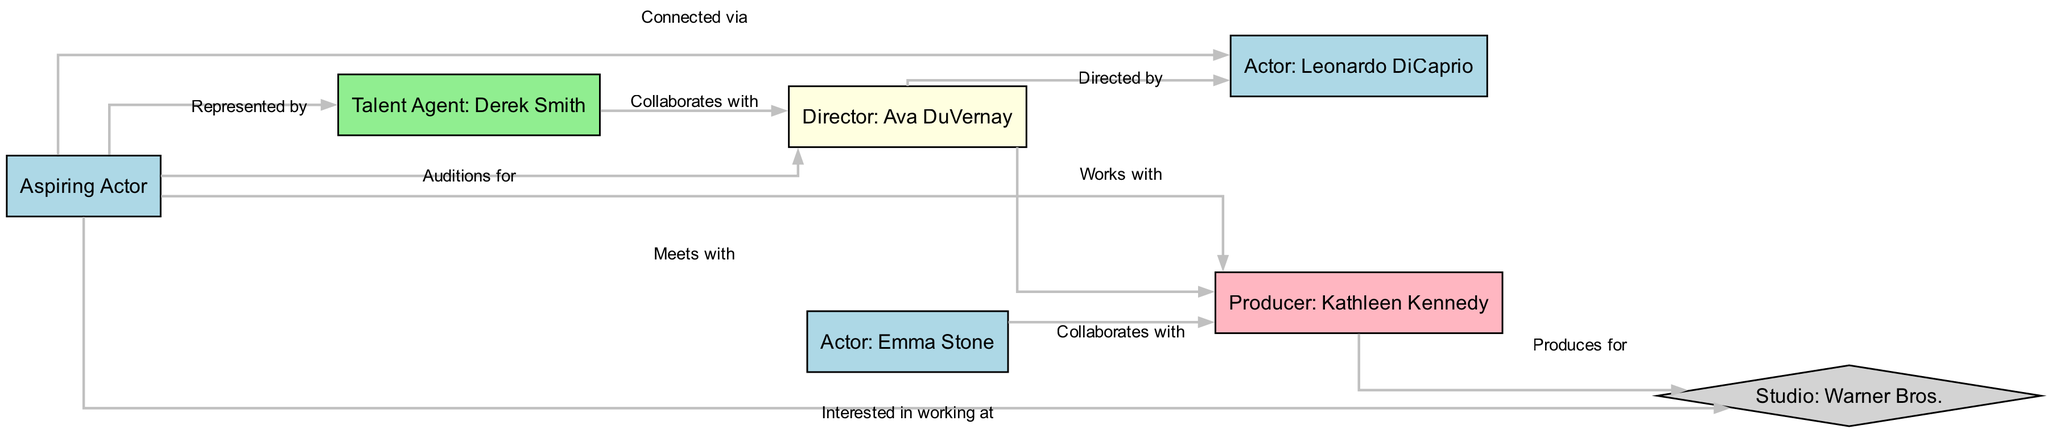How many nodes are in the diagram? To find the number of nodes, we look at the list of nodes provided. There are 6 distinct nodes representing various roles in the Hollywood network: 1 Aspiring Actor, 1 Talent Agent, 1 Director, 1 Producer, and 2 Actors. Thus, the total count is 6.
Answer: 6 What is the relationship between Aspiring Actor and Talent Agent? The Aspiring Actor is connected to the Talent Agent with an edge labeled "Represented by," indicating that the Aspiring Actor is being represented by the Talent Agent in the industry.
Answer: Represented by Who collaborates with the Director? The edges from the diagram specify that the Talent Agent collaborates with the Director, as indicated by the edge labeled "Collaborates with."
Answer: Talent Agent: Derek Smith Which actor is directed by Ava DuVernay? According to the edges, the Actor identified as Leonardo DiCaprio is directly connected to the Director with the edge labeled "Directed by," signifying that he is the one directed by Ava DuVernay.
Answer: Actor: Leonardo DiCaprio How many relationships connect the Aspiring Actor to others? By examining the edges connected to the Aspiring Actor, we can count a total of 5 relationships: Represented by Talent Agent, Auditions for Director, Connected via Actor: Leonardo DiCaprio, Meets with Producer, and Interested in working at Studio. Thus, there are 5 edges associated with the Aspiring Actor.
Answer: 5 Which studio does Kathleen Kennedy produce for? The diagram indicates that Kathleen Kennedy is connected to Warner Bros. with the edge labeled "Produces for," illustrating that she is the producer affiliated with that studio.
Answer: Warner Bros What role does Emma Stone have? From the node information, Emma Stone is labeled as "Actor," indicating her role in the Hollywood network.
Answer: Actor Which actor collaborates with Kathleen Kennedy? The diagram shows that Actor: Emma Stone collaborates with Producer: Kathleen Kennedy, as denoted by the edge labeled "Collaborates with."
Answer: Actor: Emma Stone What is the connection between the Producer and the Studio? The edge shows that Producer: Kathleen Kennedy has a relationship with Studio: Warner Bros. labeled "Produces for," indicating the Producer's professional output is associated with that Studio.
Answer: Produces for 